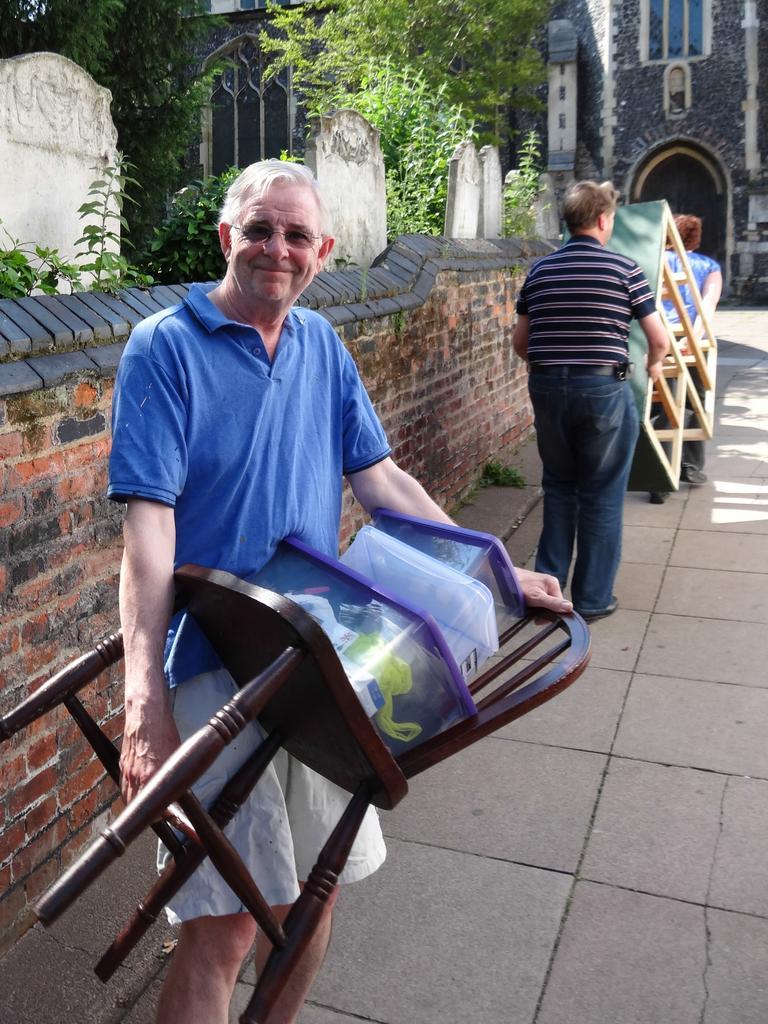Please provide a concise description of this image. This is the picture of the man holding the chair and boxes and right side of the man there are 2 persons carrying the table and the back ground we have trees, building , and a wall. 